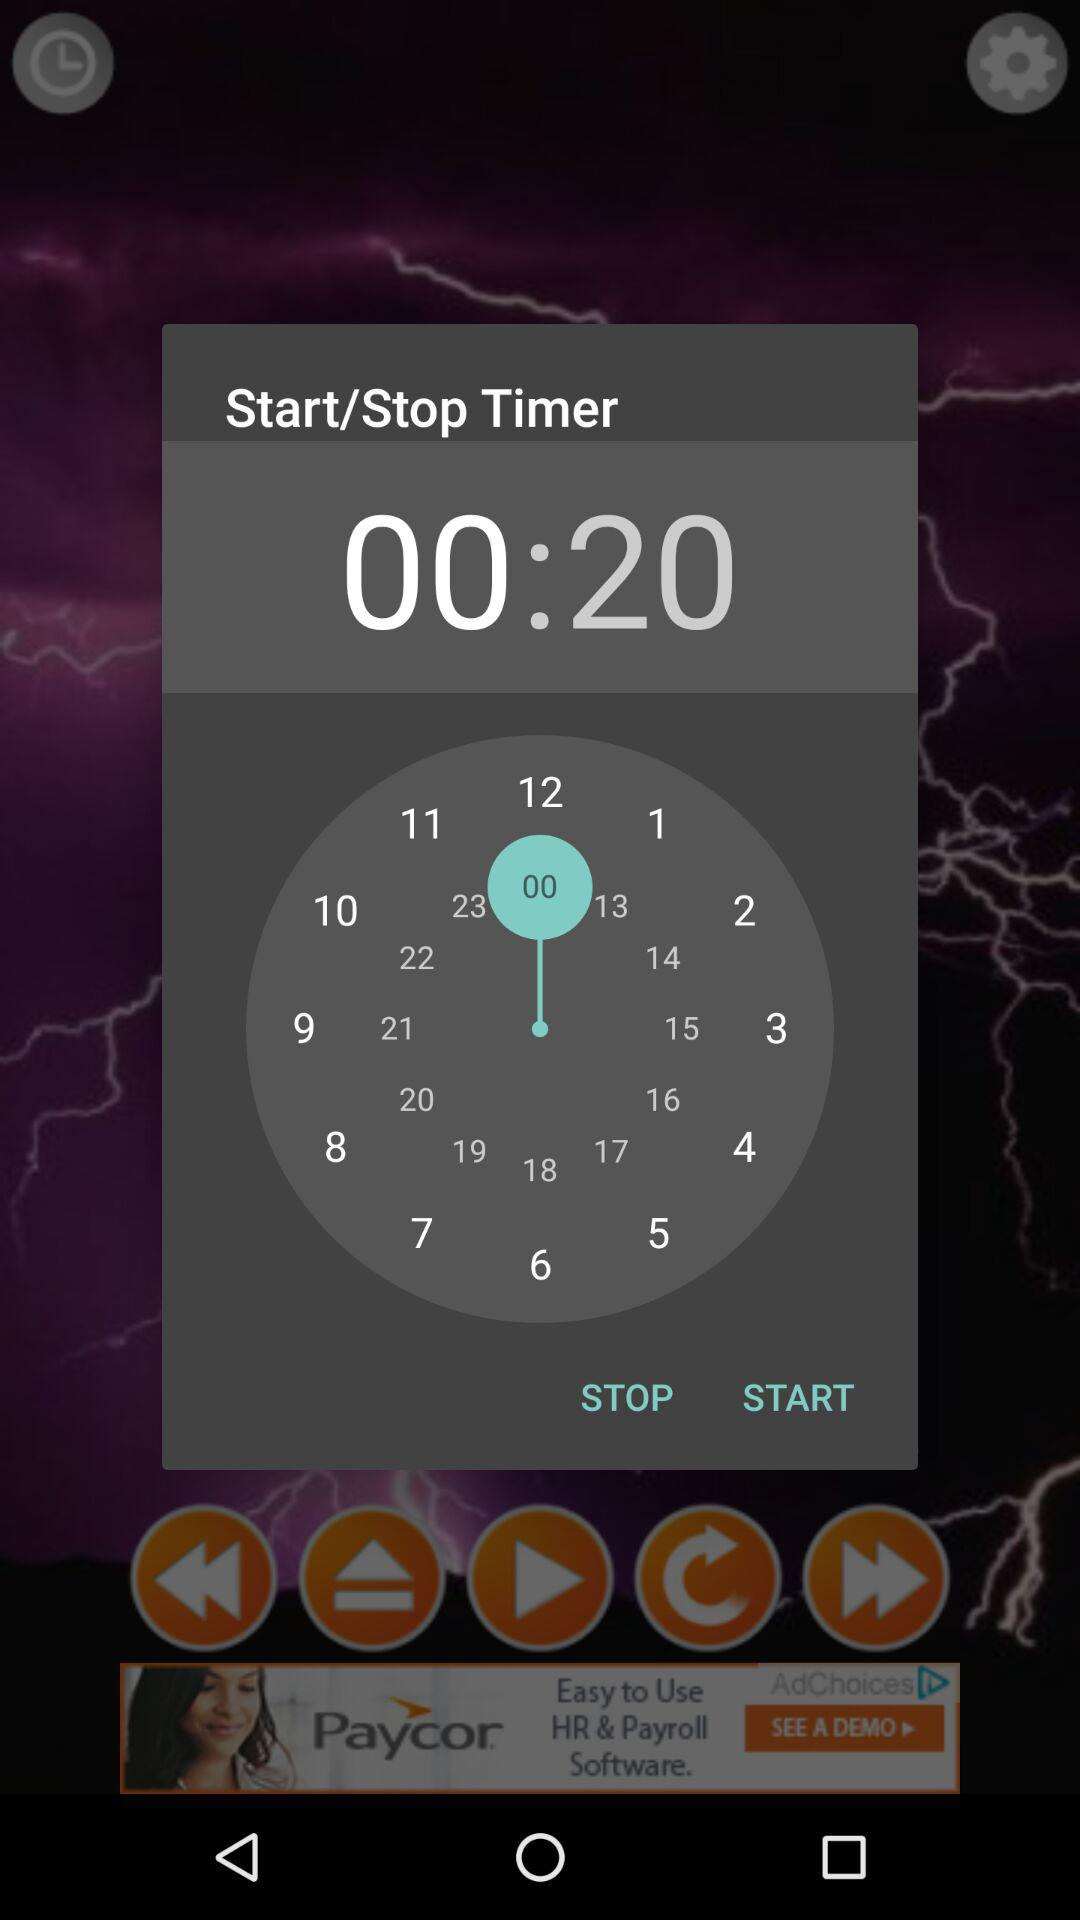How many seconds is the timer set for?
Answer the question using a single word or phrase. 20 